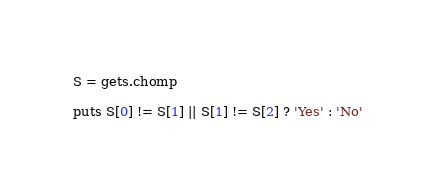<code> <loc_0><loc_0><loc_500><loc_500><_Ruby_>S = gets.chomp

puts S[0] != S[1] || S[1] != S[2] ? 'Yes' : 'No'
</code> 